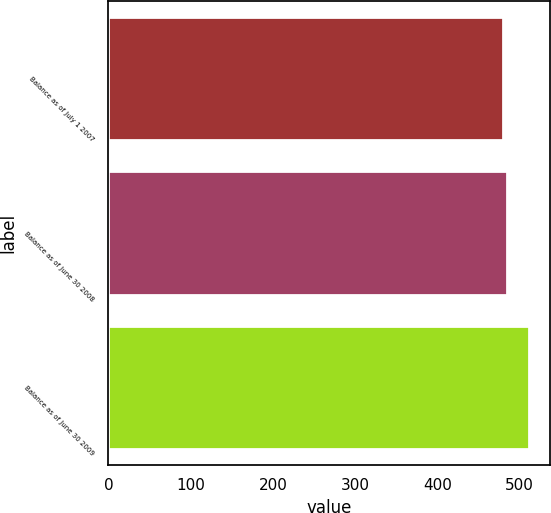Convert chart to OTSL. <chart><loc_0><loc_0><loc_500><loc_500><bar_chart><fcel>Balance as of July 1 2007<fcel>Balance as of June 30 2008<fcel>Balance as of June 30 2009<nl><fcel>480.2<fcel>484.3<fcel>511.1<nl></chart> 